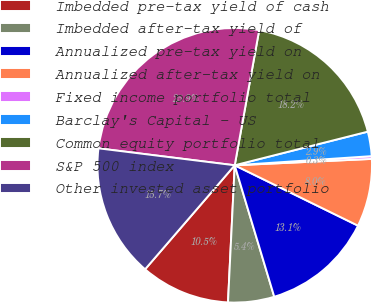Convert chart to OTSL. <chart><loc_0><loc_0><loc_500><loc_500><pie_chart><fcel>Imbedded pre-tax yield of cash<fcel>Imbedded after-tax yield of<fcel>Annualized pre-tax yield on<fcel>Annualized after-tax yield on<fcel>Fixed income portfolio total<fcel>Barclay's Capital - US<fcel>Common equity portfolio total<fcel>S&P 500 index<fcel>Other invested asset portfolio<nl><fcel>10.54%<fcel>5.43%<fcel>13.1%<fcel>7.99%<fcel>0.32%<fcel>2.88%<fcel>18.21%<fcel>25.88%<fcel>15.65%<nl></chart> 